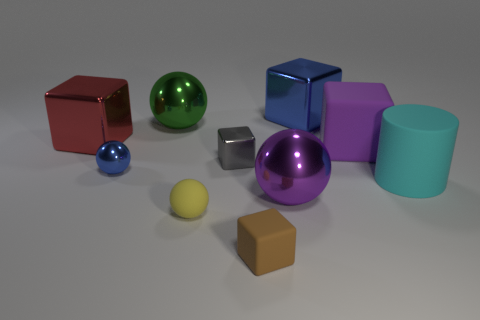Subtract all small metal blocks. How many blocks are left? 4 Subtract 1 balls. How many balls are left? 3 Subtract all red cubes. How many cubes are left? 4 Subtract all yellow cubes. Subtract all blue cylinders. How many cubes are left? 5 Subtract all cylinders. How many objects are left? 9 Add 3 tiny gray shiny objects. How many tiny gray shiny objects exist? 4 Subtract 0 gray balls. How many objects are left? 10 Subtract all large red rubber things. Subtract all tiny balls. How many objects are left? 8 Add 1 large purple objects. How many large purple objects are left? 3 